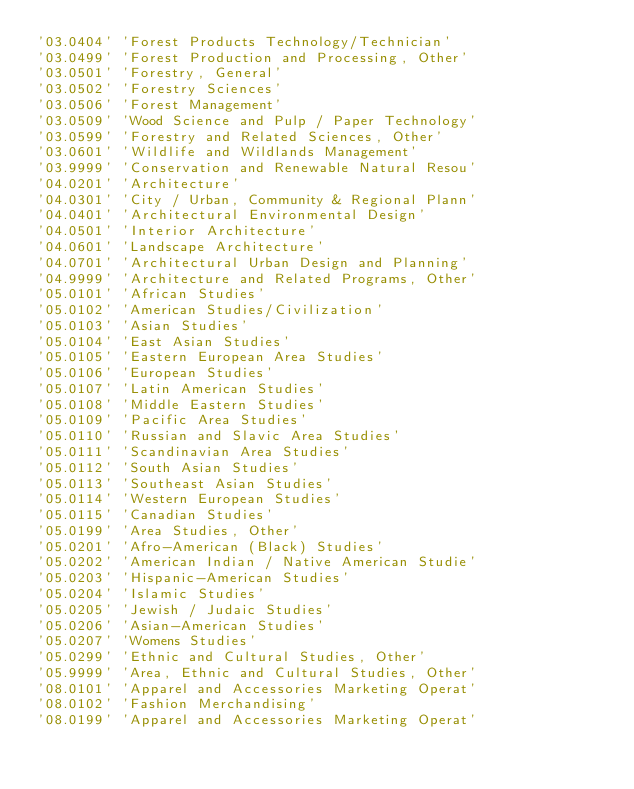<code> <loc_0><loc_0><loc_500><loc_500><_Scheme_>'03.0404' 'Forest Products Technology/Technician'
'03.0499' 'Forest Production and Processing, Other'
'03.0501' 'Forestry, General'
'03.0502' 'Forestry Sciences'
'03.0506' 'Forest Management'
'03.0509' 'Wood Science and Pulp / Paper Technology'
'03.0599' 'Forestry and Related Sciences, Other'
'03.0601' 'Wildlife and Wildlands Management'
'03.9999' 'Conservation and Renewable Natural Resou'
'04.0201' 'Architecture'
'04.0301' 'City / Urban, Community & Regional Plann'
'04.0401' 'Architectural Environmental Design'
'04.0501' 'Interior Architecture'
'04.0601' 'Landscape Architecture'
'04.0701' 'Architectural Urban Design and Planning'
'04.9999' 'Architecture and Related Programs, Other'
'05.0101' 'African Studies'
'05.0102' 'American Studies/Civilization'
'05.0103' 'Asian Studies'
'05.0104' 'East Asian Studies'
'05.0105' 'Eastern European Area Studies'
'05.0106' 'European Studies'
'05.0107' 'Latin American Studies'
'05.0108' 'Middle Eastern Studies'
'05.0109' 'Pacific Area Studies'
'05.0110' 'Russian and Slavic Area Studies'
'05.0111' 'Scandinavian Area Studies'
'05.0112' 'South Asian Studies'
'05.0113' 'Southeast Asian Studies'
'05.0114' 'Western European Studies'
'05.0115' 'Canadian Studies'
'05.0199' 'Area Studies, Other'
'05.0201' 'Afro-American (Black) Studies'
'05.0202' 'American Indian / Native American Studie'
'05.0203' 'Hispanic-American Studies'
'05.0204' 'Islamic Studies'
'05.0205' 'Jewish / Judaic Studies'
'05.0206' 'Asian-American Studies'
'05.0207' 'Womens Studies'
'05.0299' 'Ethnic and Cultural Studies, Other'
'05.9999' 'Area, Ethnic and Cultural Studies, Other'
'08.0101' 'Apparel and Accessories Marketing Operat'
'08.0102' 'Fashion Merchandising'
'08.0199' 'Apparel and Accessories Marketing Operat'</code> 